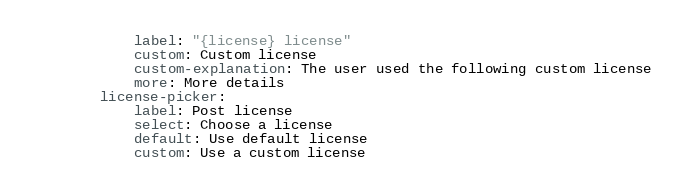<code> <loc_0><loc_0><loc_500><loc_500><_YAML_>            label: "{license} license"
            custom: Custom license
            custom-explanation: The user used the following custom license
            more: More details
        license-picker:
            label: Post license
            select: Choose a license
            default: Use default license
            custom: Use a custom license
</code> 